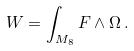<formula> <loc_0><loc_0><loc_500><loc_500>W = \int _ { M _ { 8 } } F \wedge \Omega \, .</formula> 